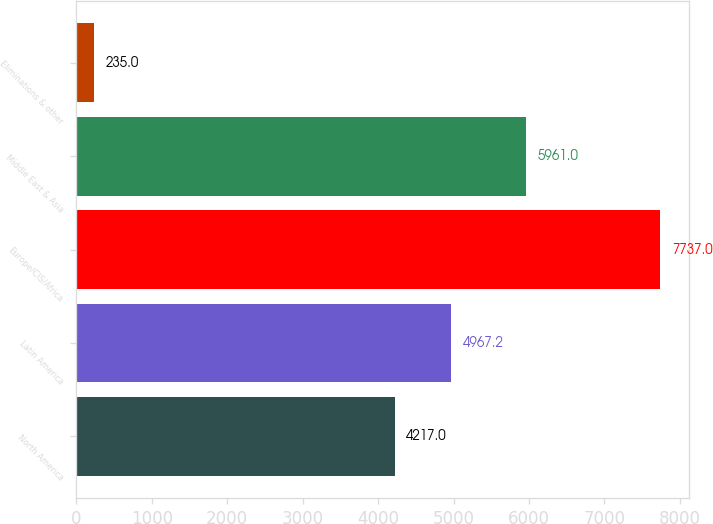Convert chart to OTSL. <chart><loc_0><loc_0><loc_500><loc_500><bar_chart><fcel>North America<fcel>Latin America<fcel>Europe/CIS/Africa<fcel>Middle East & Asia<fcel>Eliminations & other<nl><fcel>4217<fcel>4967.2<fcel>7737<fcel>5961<fcel>235<nl></chart> 